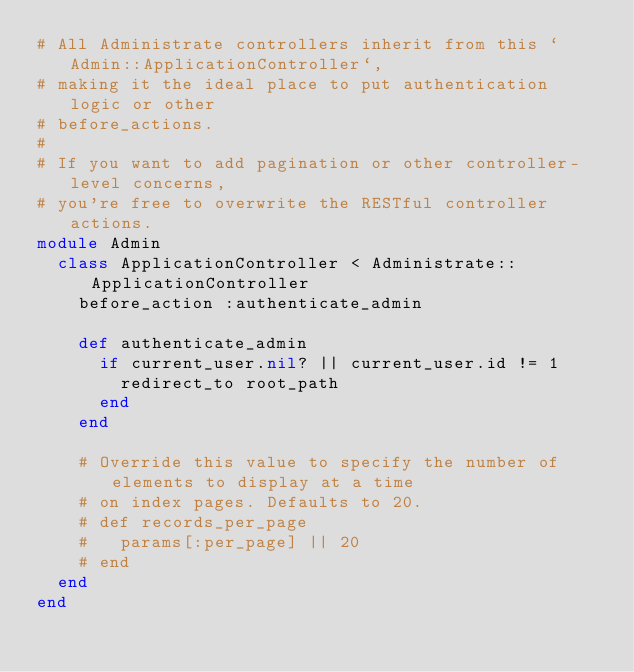<code> <loc_0><loc_0><loc_500><loc_500><_Ruby_># All Administrate controllers inherit from this `Admin::ApplicationController`,
# making it the ideal place to put authentication logic or other
# before_actions.
#
# If you want to add pagination or other controller-level concerns,
# you're free to overwrite the RESTful controller actions.
module Admin
  class ApplicationController < Administrate::ApplicationController
    before_action :authenticate_admin

    def authenticate_admin
      if current_user.nil? || current_user.id != 1
        redirect_to root_path
      end
    end

    # Override this value to specify the number of elements to display at a time
    # on index pages. Defaults to 20.
    # def records_per_page
    #   params[:per_page] || 20
    # end
  end
end
</code> 